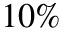<formula> <loc_0><loc_0><loc_500><loc_500>1 0 \%</formula> 